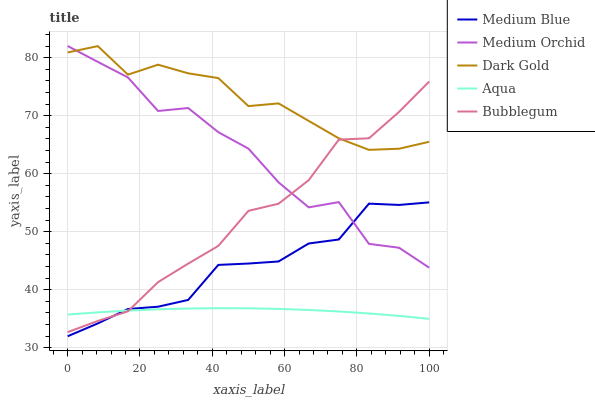Does Aqua have the minimum area under the curve?
Answer yes or no. Yes. Does Dark Gold have the maximum area under the curve?
Answer yes or no. Yes. Does Medium Orchid have the minimum area under the curve?
Answer yes or no. No. Does Medium Orchid have the maximum area under the curve?
Answer yes or no. No. Is Aqua the smoothest?
Answer yes or no. Yes. Is Medium Orchid the roughest?
Answer yes or no. Yes. Is Medium Blue the smoothest?
Answer yes or no. No. Is Medium Blue the roughest?
Answer yes or no. No. Does Medium Blue have the lowest value?
Answer yes or no. Yes. Does Medium Orchid have the lowest value?
Answer yes or no. No. Does Medium Orchid have the highest value?
Answer yes or no. Yes. Does Medium Blue have the highest value?
Answer yes or no. No. Is Aqua less than Dark Gold?
Answer yes or no. Yes. Is Medium Orchid greater than Aqua?
Answer yes or no. Yes. Does Medium Blue intersect Bubblegum?
Answer yes or no. Yes. Is Medium Blue less than Bubblegum?
Answer yes or no. No. Is Medium Blue greater than Bubblegum?
Answer yes or no. No. Does Aqua intersect Dark Gold?
Answer yes or no. No. 